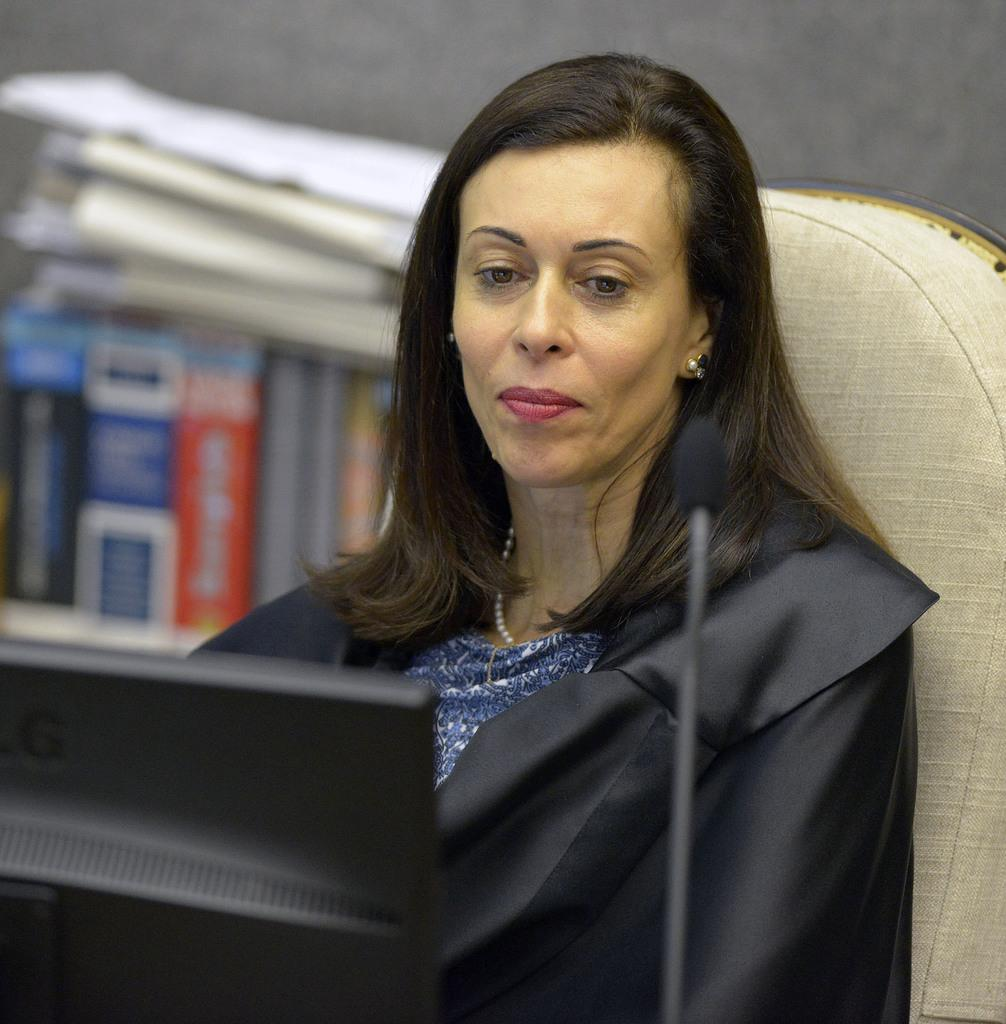What is the lady in the image doing? The lady is sitting on a chair in the image. What is the lady wearing in the image? The lady is wearing a coat in the image. What electronic device can be seen in the image? There is a monitor in the image. What device is used for amplifying sound in the image? There is a microphone (mic) in the image. What can be seen in the background of the image? There are books and papers in the background of the image. What type of underwear is the lady wearing in the image? There is no information about the lady's underwear in the image, as the focus is on her coat. 